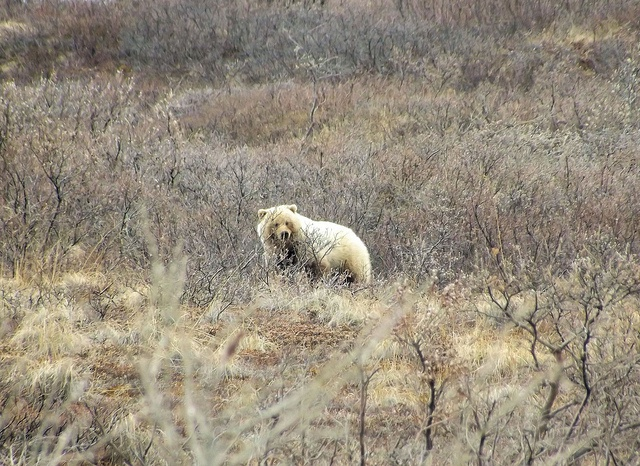Describe the objects in this image and their specific colors. I can see a bear in gray, ivory, darkgray, and tan tones in this image. 